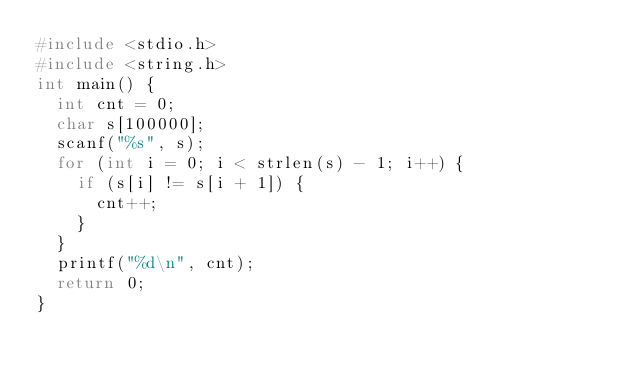Convert code to text. <code><loc_0><loc_0><loc_500><loc_500><_C_>#include <stdio.h>
#include <string.h>
int main() {
	int cnt = 0;
	char s[100000];
	scanf("%s", s);
	for (int i = 0; i < strlen(s) - 1; i++) {
		if (s[i] != s[i + 1]) {
			cnt++;
		}
	}
	printf("%d\n", cnt);
	return 0;
}</code> 